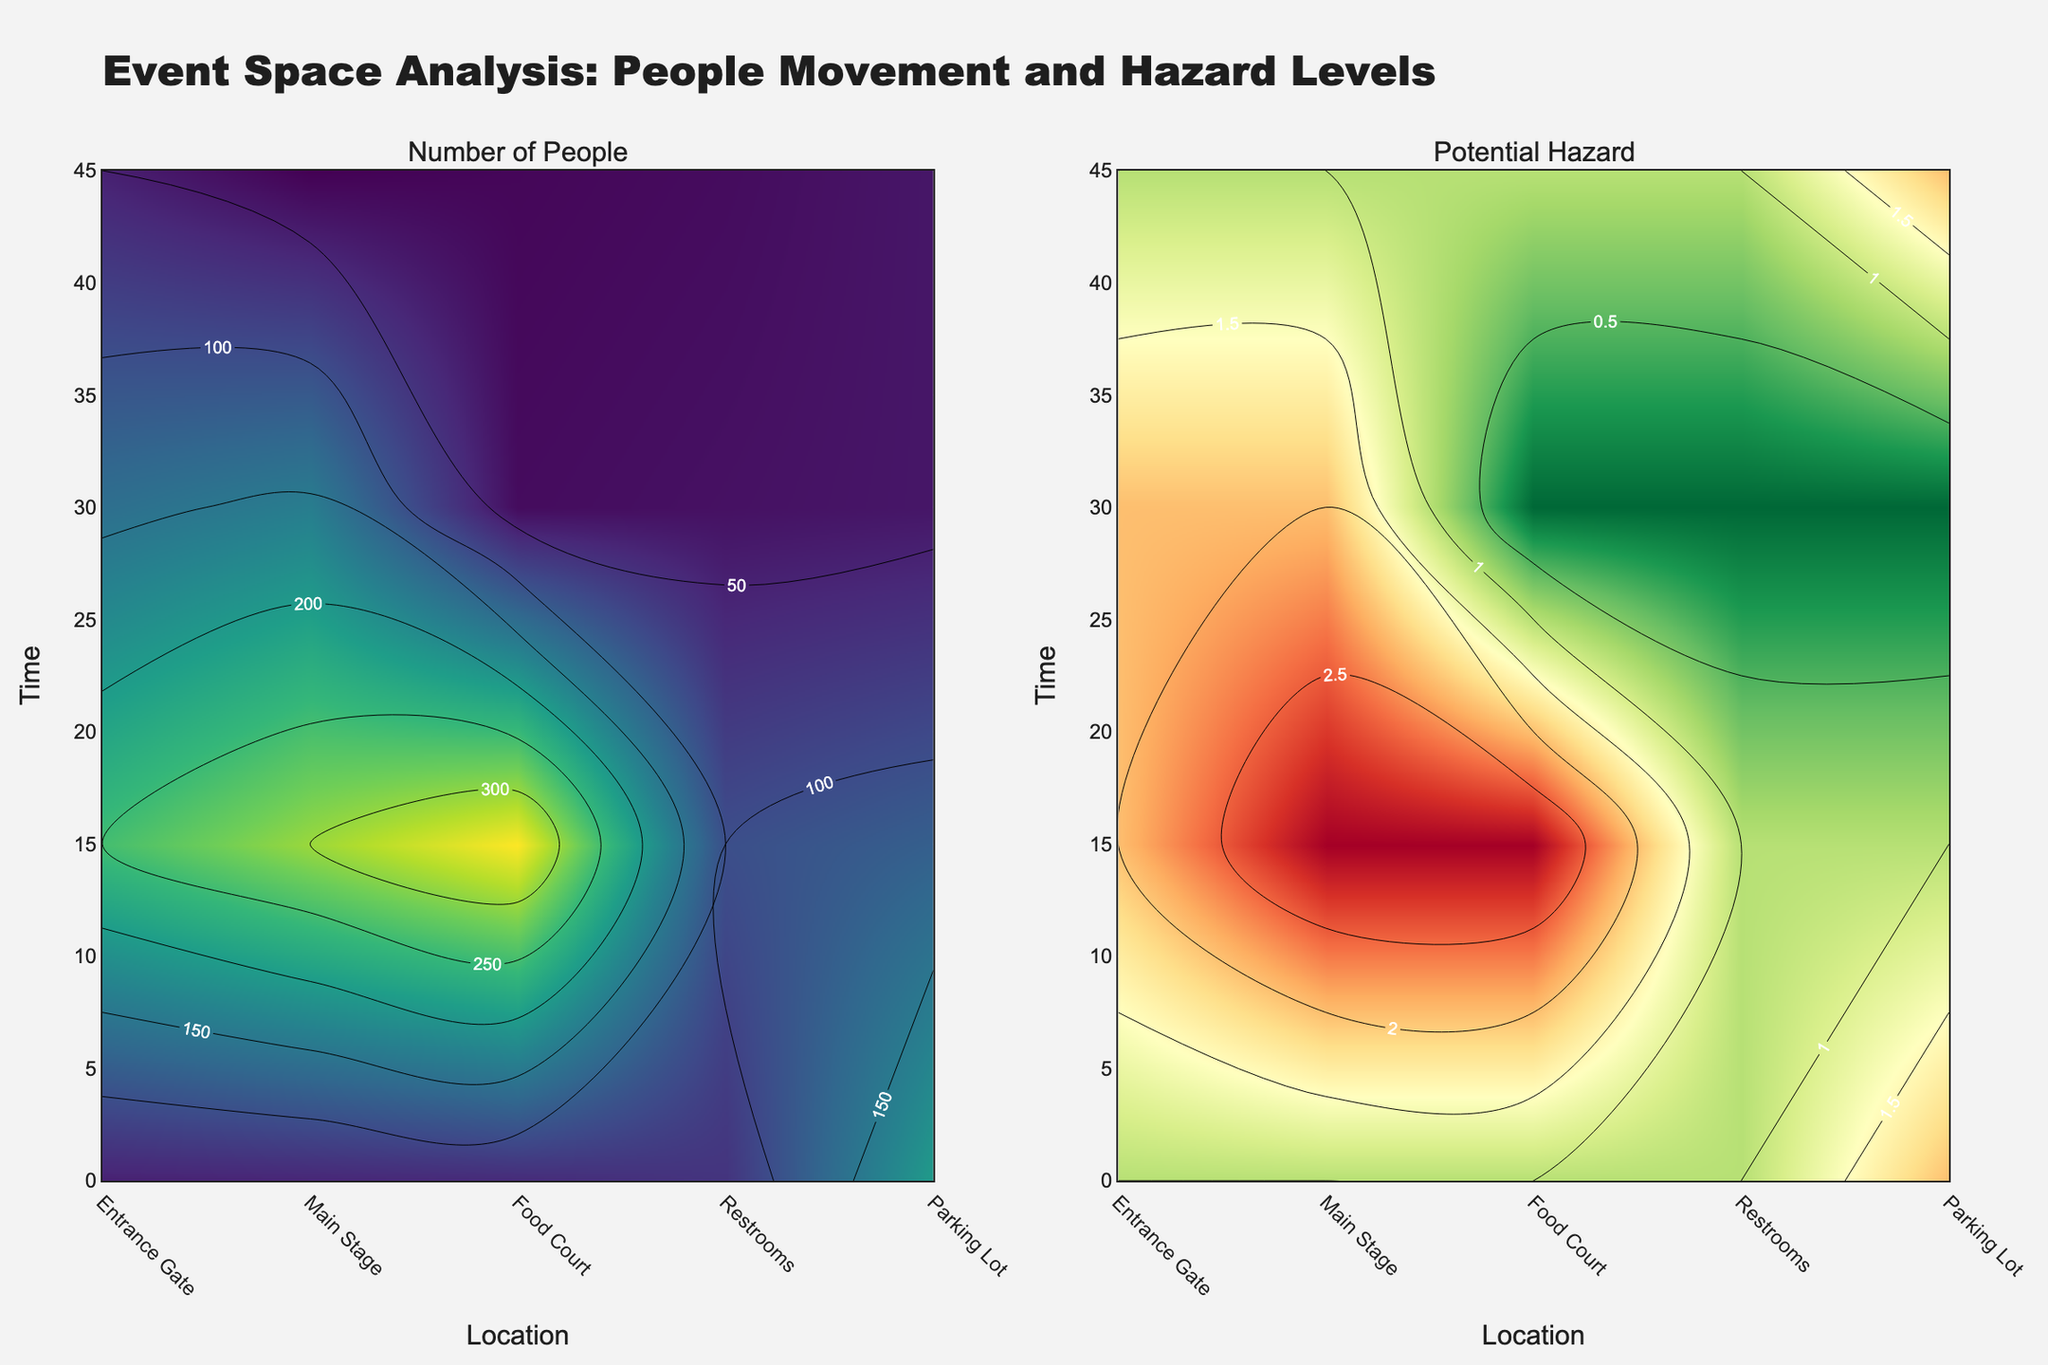How many unique locations are shown on the contour plot? The x-axis of the contour plot displays the unique locations. According to the dataset, unique locations include Entrance Gate, Main Stage, Food Court, Restrooms, and Parking Lot.
Answer: 5 What is the title of the figure? The figure displays the title at the top of the plot, which summarizes the purpose of the visualization.
Answer: Event Space Analysis: People Movement and Hazard Levels At what location and time is the highest number of people recorded? By examining the contour plot for the "Number of People," we identify the location with the darkest color representing the highest values. The Main Stage at 12:45 shows the highest number of people.
Answer: Main Stage, 12:45 Which location has the lowest potential hazard at 12:45? By analyzing the contour plot for "Potential Hazard" at 12:45, we look for the location that has the lowest contour values. Restrooms have the lowest potential hazard at this time.
Answer: Restrooms How does the number of people at the Main Stage change from 12:00 to 12:45? Observe the color gradient in the "Number of People" plot for the Main Stage from 12:00 to 12:45. The number of people increases as time progresses.
Answer: Increases Which location has the most significant increase in potential hazard from 12:00 to 12:45? Identify the location with the most pronounced color change in the "Potential Hazard" contour plot from 12:00 to 12:45. The Main Stage shows the most significant increase.
Answer: Main Stage Compare the potential hazard levels between Entrance Gate and Parking Lot at 12:30. Which one is higher and by how much? Check the "Potential Hazard" plot values at 12:30 for both locations. The Entrance Gate has a level of 1, while the Parking Lot has a level of 1 at 12:30. Therefore, the hazard levels are equal.
Answer: Equal What is the primary color scheme used in the "Number of People" contour plot? The primary color scheme conveys the density of people, ranging from light (fewer people) to dark (more people). The "Number of People" contour plot uses the Viridis color scale.
Answer: Viridis Identify the time period with the fewest people in the Food Court. Examine the "Number of People" contour plot at the Food Court's position for the lightest color, indicating the lowest density. The fewest people are present at 12:00.
Answer: 12:00 Which location has potential hazard levels that remain constant for the provided times? Look for a location where the colors in the "Potential Hazard" plot do not change over different times. The Restrooms show relatively constant hazard levels except a slight increase at 12:45.
Answer: Restrooms 